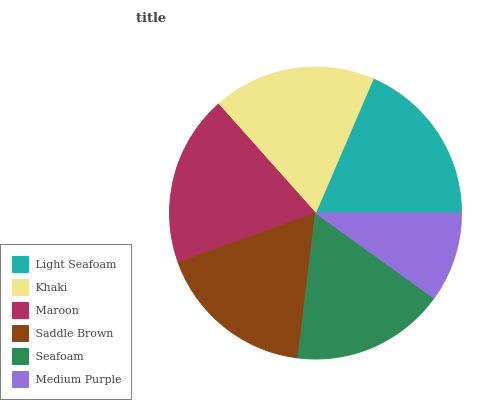Is Medium Purple the minimum?
Answer yes or no. Yes. Is Maroon the maximum?
Answer yes or no. Yes. Is Khaki the minimum?
Answer yes or no. No. Is Khaki the maximum?
Answer yes or no. No. Is Light Seafoam greater than Khaki?
Answer yes or no. Yes. Is Khaki less than Light Seafoam?
Answer yes or no. Yes. Is Khaki greater than Light Seafoam?
Answer yes or no. No. Is Light Seafoam less than Khaki?
Answer yes or no. No. Is Khaki the high median?
Answer yes or no. Yes. Is Saddle Brown the low median?
Answer yes or no. Yes. Is Seafoam the high median?
Answer yes or no. No. Is Medium Purple the low median?
Answer yes or no. No. 